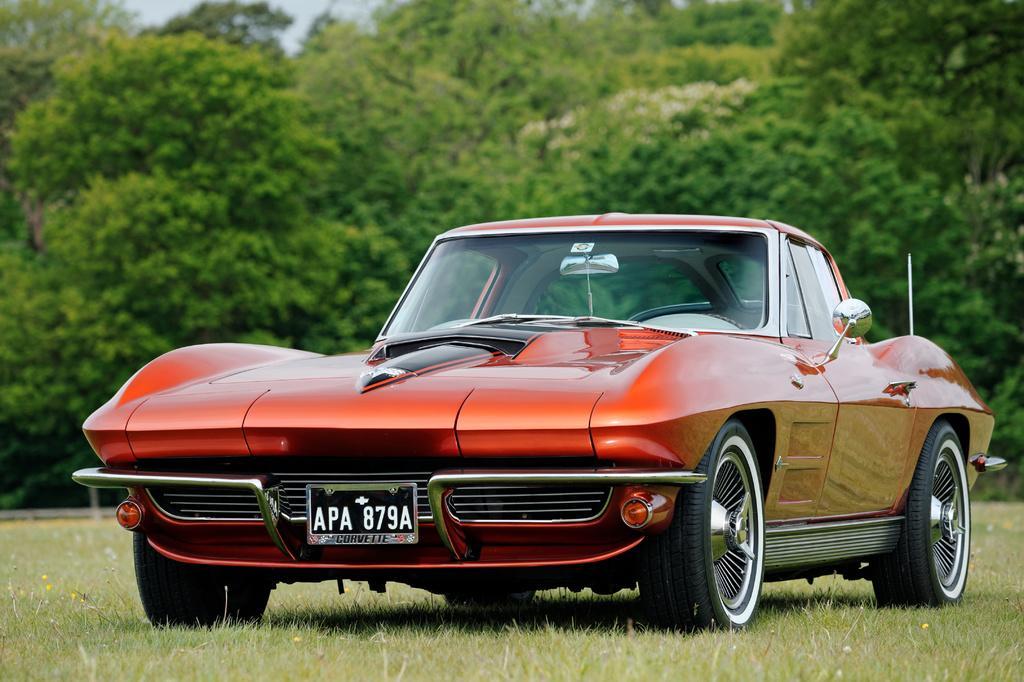Could you give a brief overview of what you see in this image? In this image we can see a car, grass, trees, at the top we can see the sky. 